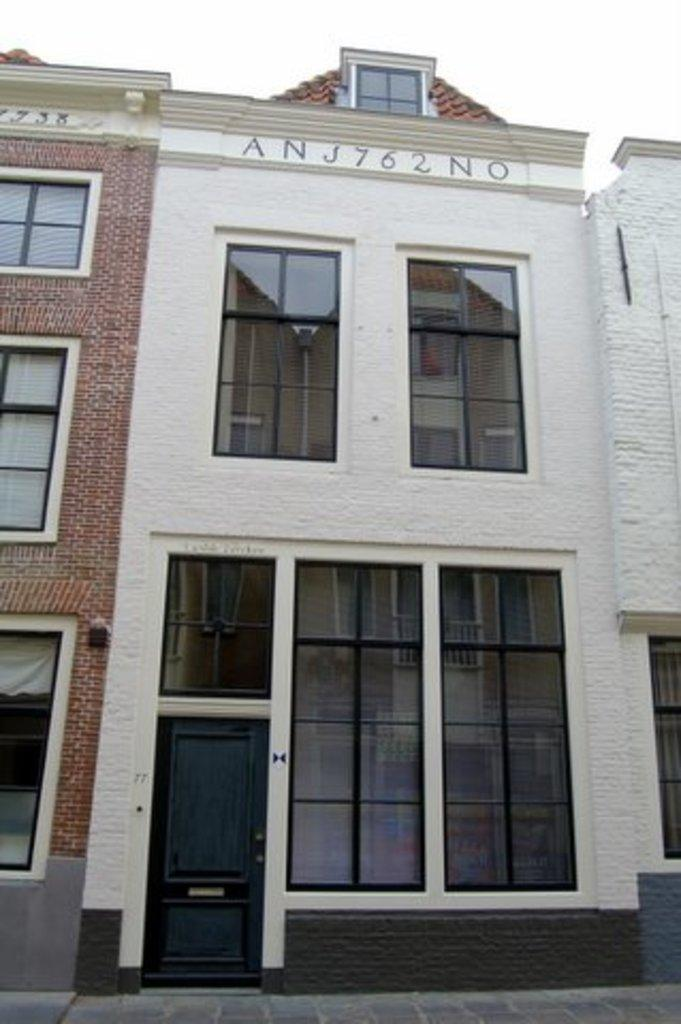What is the main subject of the image? The main subject of the image is a building. Can you describe the building in the image? The building has windows. What is visible at the top of the image? The sky is visible at the top of the image. What type of holiday is being celebrated in the image? There is no indication of a holiday being celebrated in the image, as it only features a building with windows and the sky. Can you see any wilderness or natural landscapes in the image? The image only shows a building and the sky, so there is no wilderness or natural landscapes present. 